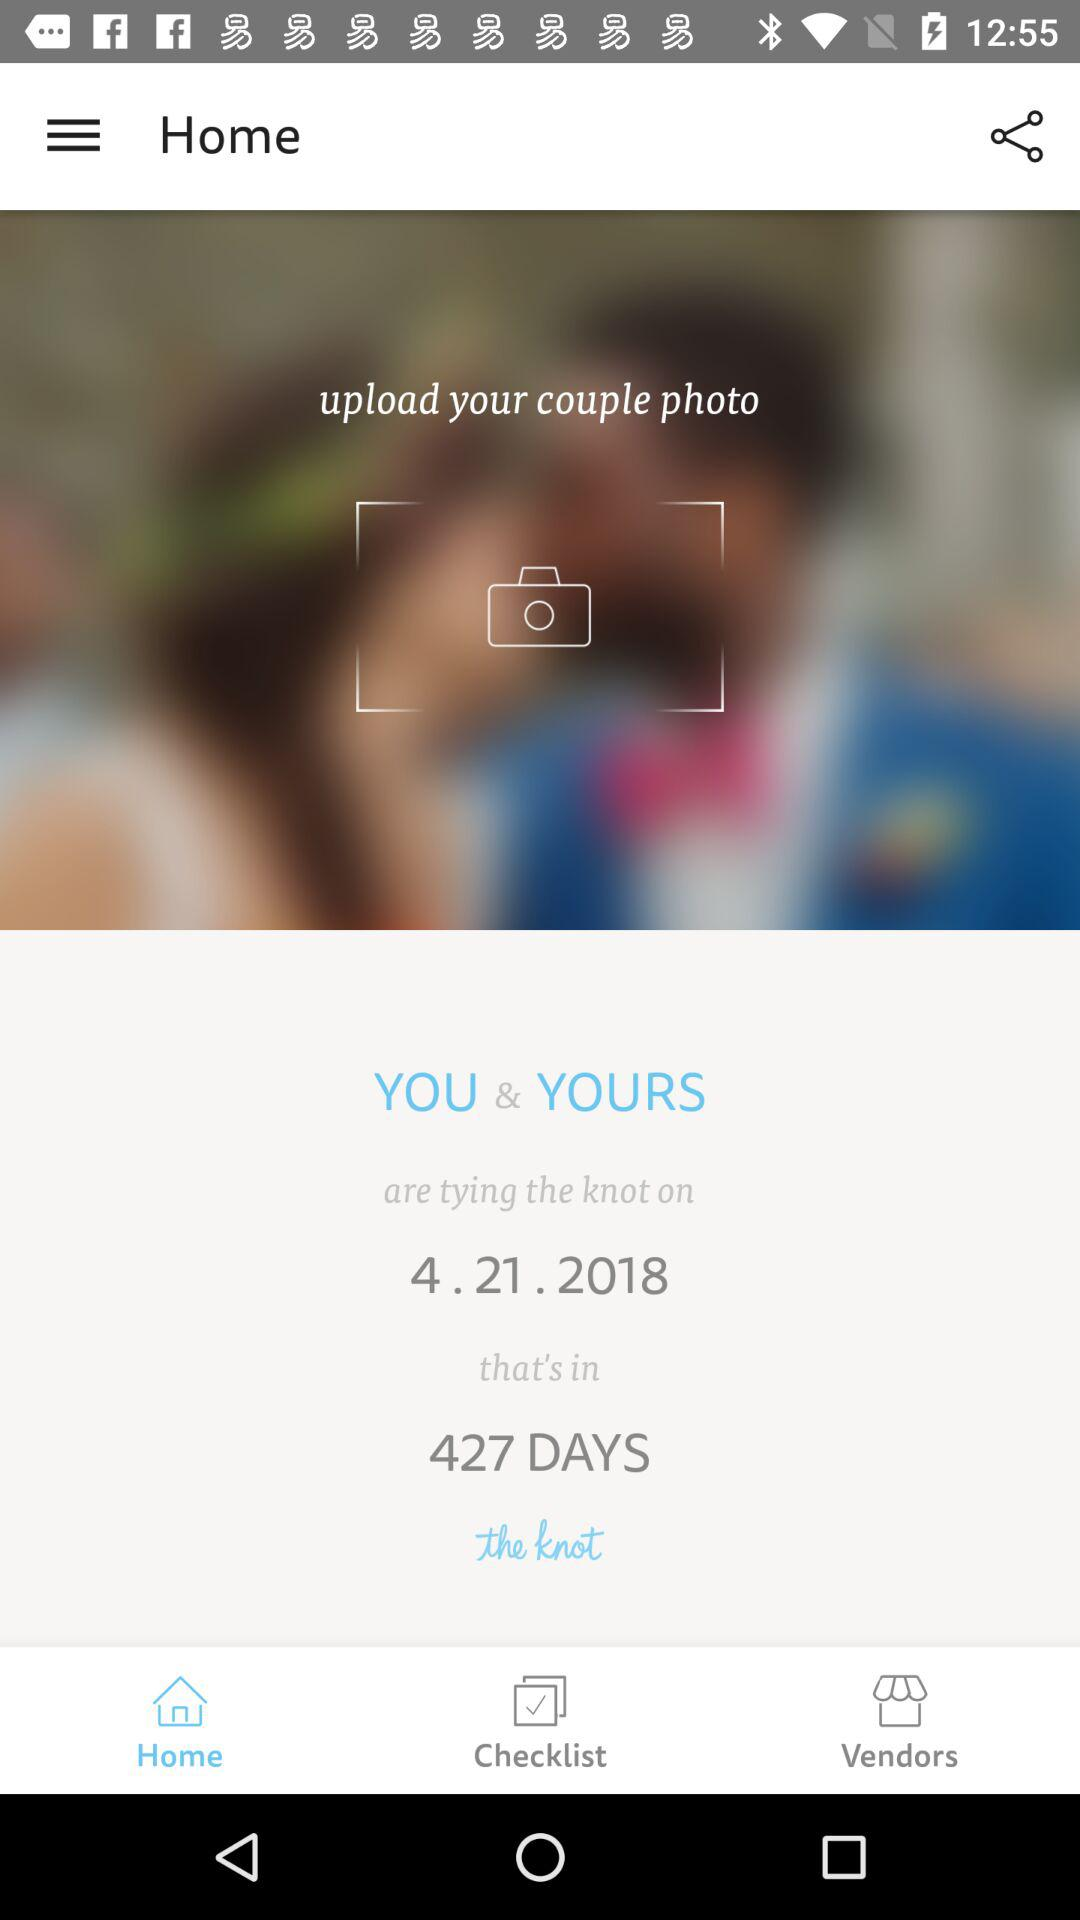Which tab is selected? The selected tab is Home. 